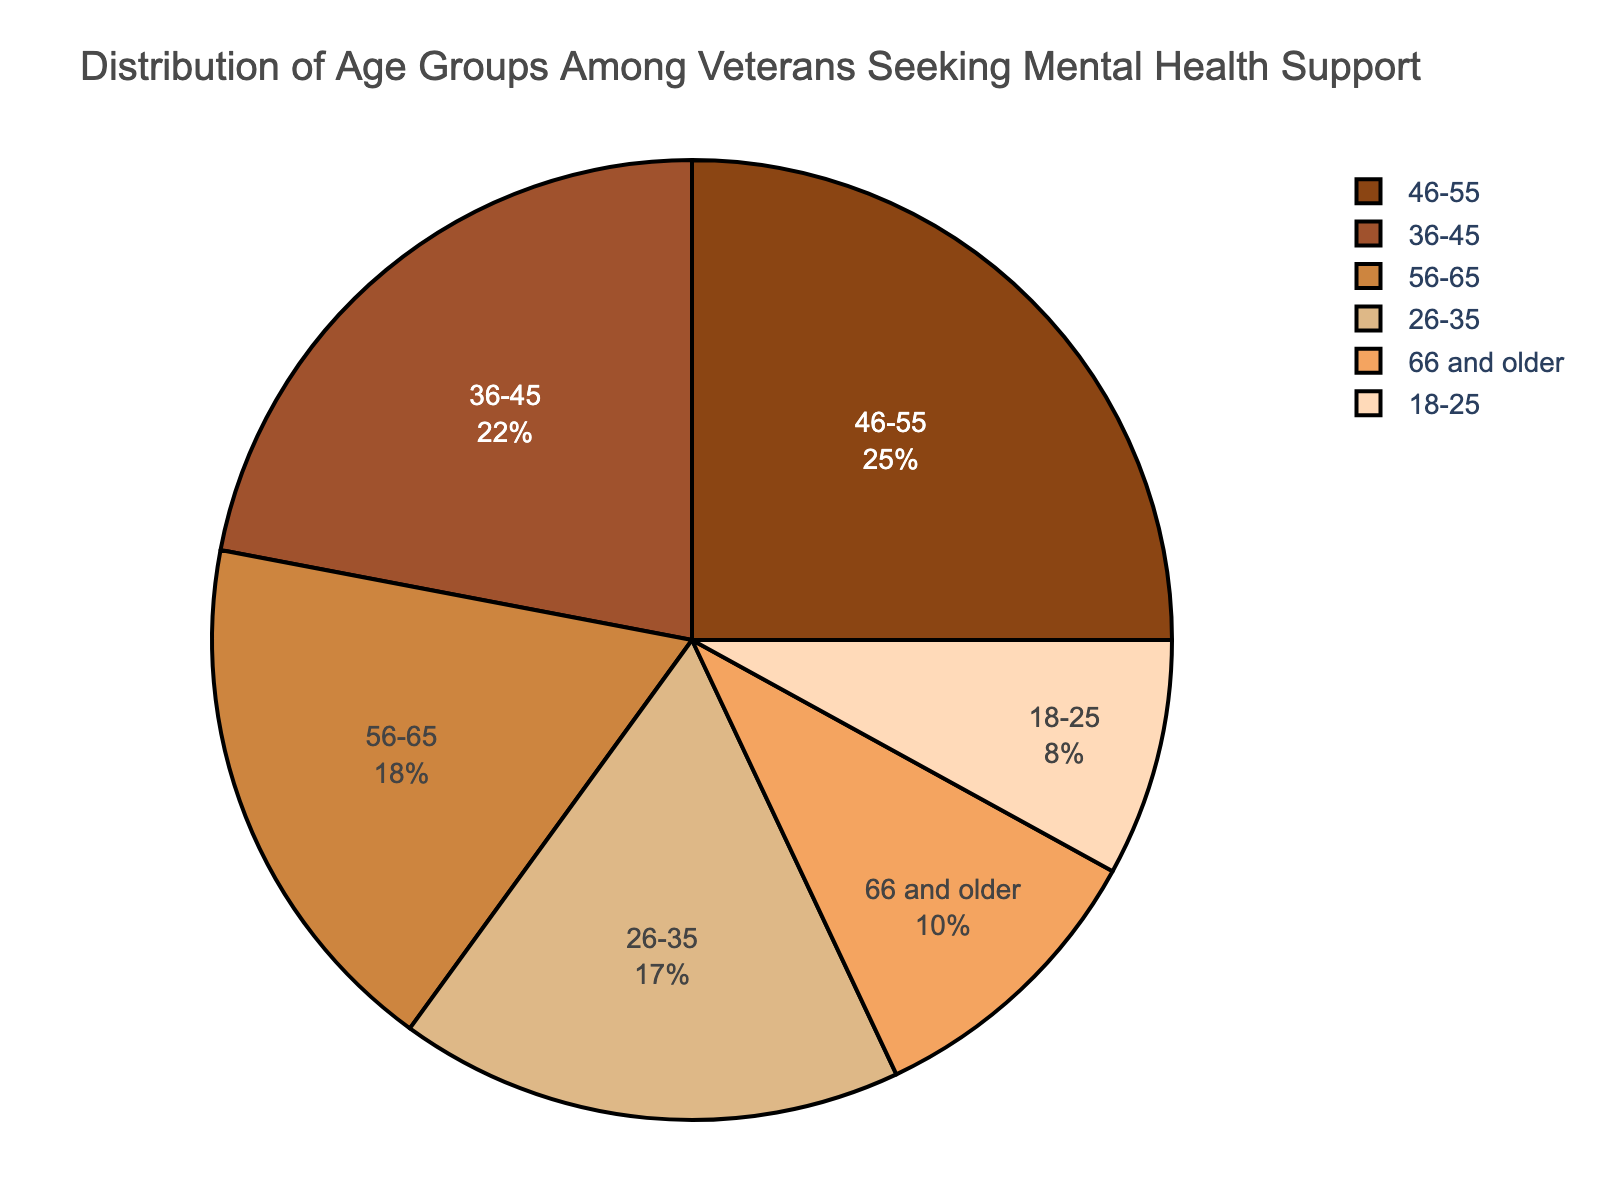What is the age group with the highest percentage of veterans seeking mental health support? The figure shows that the age group with the highest percentage is 46-55.
Answer: 46-55 Which two age groups have the closest percentage values, and what is their difference? The age groups 56-65 and 66 and older have percentages of 18 and 10 respectively; the difference is 18 - 10 = 8.
Answer: 56-65 and 66 and older, 8 What is the combined percentage of veterans seeking mental health support in the age groups 26-35 and 36-45? Add the percentages of the two age groups: 17% (26-35) + 22% (36-45) = 39%.
Answer: 39% Which age group has a percentage that is exactly double of another age group, and which are these groups? The percentage of the age group 46-55 is 25%, which is double the percentage of the 18-25 age group, 8%.
Answer: 46-55 and 18-25 How much more percentage of veterans are seeking mental health support in the 46-55 age group compared to the 66 and older age group? Subtract the percentage of the 66 and older group from the 46-55 group: 25% - 10% = 15%.
Answer: 15% Which age group has a percentage closest to the average percentage of all age groups combined? The average percentage can be calculated by adding all the percentages and dividing by the number of groups: (8% + 17% + 22% + 25% + 18% + 10%) / 6 = 16.67%. The 18-25 group has 18%, which is the closest to the average.
Answer: 56-65 What is the total percentage of veterans in the age groups 36-45 and 46-55 combined, and how does it compare to the total percentages of the remaining age groups? The combined percentage of 36-45 and 46-55 is 22% + 25% = 47%. The remaining age groups' total percentage is 8% (18-25) + 17% (26-35) + 18% (56-65) + 10% (66 and older) = 53%.
Answer: 47%, 53% What proportion of the total percentage is represented by the 26-35 age group? To find the proportion, divide the percentage of the 26-35 age group by the total percentage (100%): 17% / 100% = 0.17 or 17%.
Answer: 17% If the number of veterans seeking mental health support is 1000, how many veterans fall into the age group 36-45? Calculate the number by taking 22% of 1000: 0.22 * 1000 = 220.
Answer: 220 Which age group color is used to represent the 18-25 group in the pie chart? The pie chart uses the color at the first position of the custom color palette for the 18-25 group, which is brown (#8B4513).
Answer: Brown 